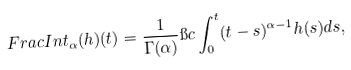<formula> <loc_0><loc_0><loc_500><loc_500>\ F r a c I n t _ { \alpha } ( h ) ( t ) = \frac { 1 } { \Gamma ( \alpha ) } \i c \int _ { 0 } ^ { t } ( t - s ) ^ { \alpha - 1 } h ( s ) d s ,</formula> 